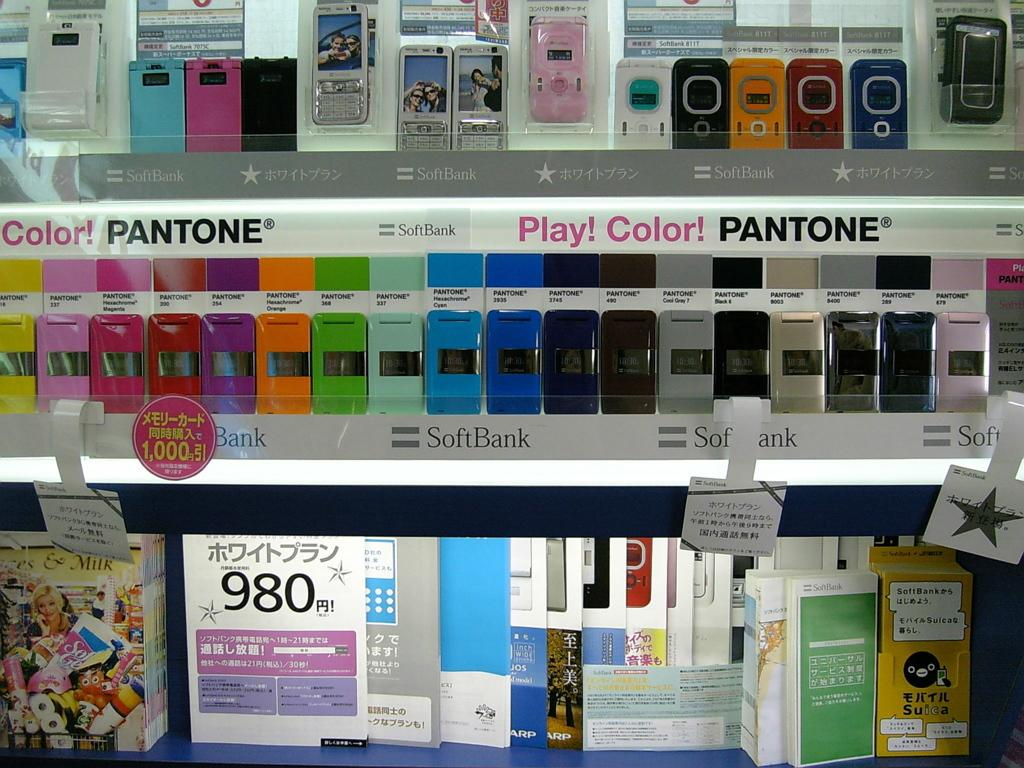Provide a one-sentence caption for the provided image. A bunch of cellphones are on two shelves marked with advertisements for Pantone and SoftBank. 